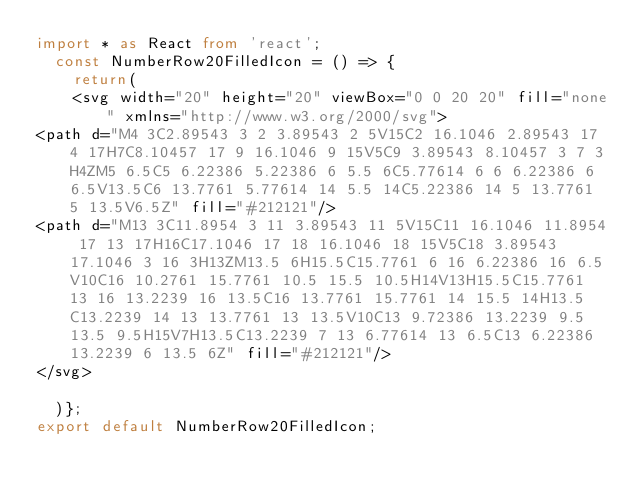Convert code to text. <code><loc_0><loc_0><loc_500><loc_500><_TypeScript_>import * as React from 'react';
  const NumberRow20FilledIcon = () => {
    return(
    <svg width="20" height="20" viewBox="0 0 20 20" fill="none" xmlns="http://www.w3.org/2000/svg">
<path d="M4 3C2.89543 3 2 3.89543 2 5V15C2 16.1046 2.89543 17 4 17H7C8.10457 17 9 16.1046 9 15V5C9 3.89543 8.10457 3 7 3H4ZM5 6.5C5 6.22386 5.22386 6 5.5 6C5.77614 6 6 6.22386 6 6.5V13.5C6 13.7761 5.77614 14 5.5 14C5.22386 14 5 13.7761 5 13.5V6.5Z" fill="#212121"/>
<path d="M13 3C11.8954 3 11 3.89543 11 5V15C11 16.1046 11.8954 17 13 17H16C17.1046 17 18 16.1046 18 15V5C18 3.89543 17.1046 3 16 3H13ZM13.5 6H15.5C15.7761 6 16 6.22386 16 6.5V10C16 10.2761 15.7761 10.5 15.5 10.5H14V13H15.5C15.7761 13 16 13.2239 16 13.5C16 13.7761 15.7761 14 15.5 14H13.5C13.2239 14 13 13.7761 13 13.5V10C13 9.72386 13.2239 9.5 13.5 9.5H15V7H13.5C13.2239 7 13 6.77614 13 6.5C13 6.22386 13.2239 6 13.5 6Z" fill="#212121"/>
</svg>

  )};
export default NumberRow20FilledIcon;
</code> 